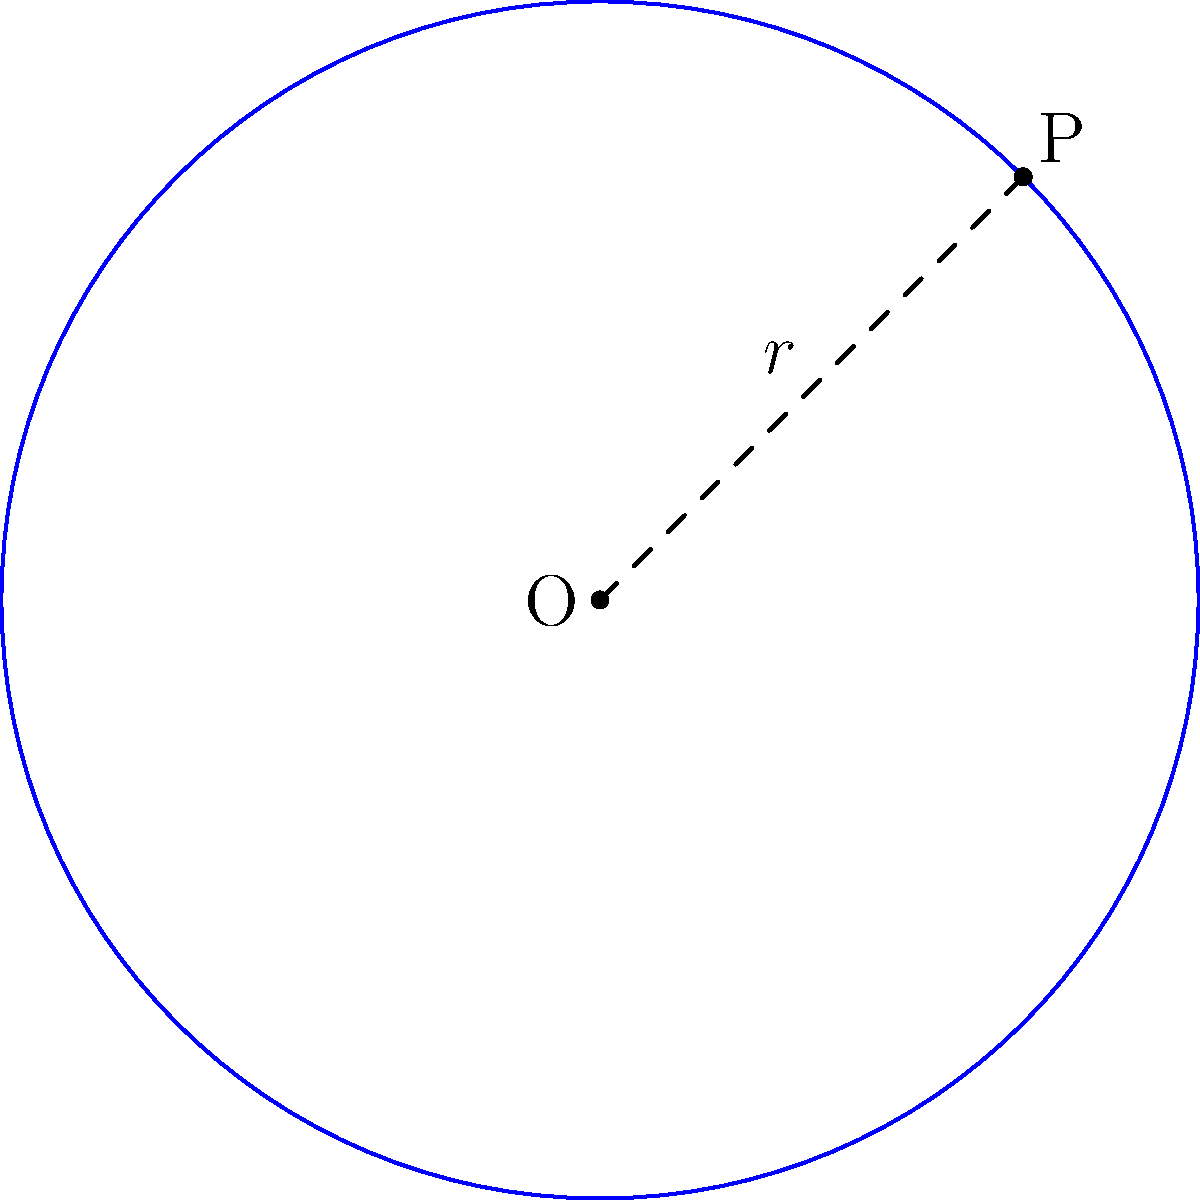As a software engineer working on a project that involves geometric calculations, you need to determine the equation of a circle for a UX design element. Given that the center of the circle is at point O(2,3) and point P(5,6) lies on its circumference, derive the equation of the circle. Let's approach this step-by-step:

1) The general equation of a circle is $$(x-h)^2 + (y-k)^2 = r^2$$
   where (h,k) is the center and r is the radius.

2) We're given the center O(2,3), so h=2 and k=3.

3) To find r, we need to calculate the distance between O(2,3) and P(5,6):
   $$r^2 = (x_P-x_O)^2 + (y_P-y_O)^2 = (5-2)^2 + (6-3)^2 = 3^2 + 3^2 = 18$$

4) Now we have all the components to form the equation:
   $$(x-2)^2 + (y-3)^2 = 18$$

5) This is the equation of the circle in its standard form.

6) If we expand this, we get:
   $$x^2-4x+4 + y^2-6y+9 = 18$$
   $$x^2+y^2-4x-6y-5 = 0$$

This expanded form might be useful in certain programming contexts.
Answer: $(x-2)^2 + (y-3)^2 = 18$ 